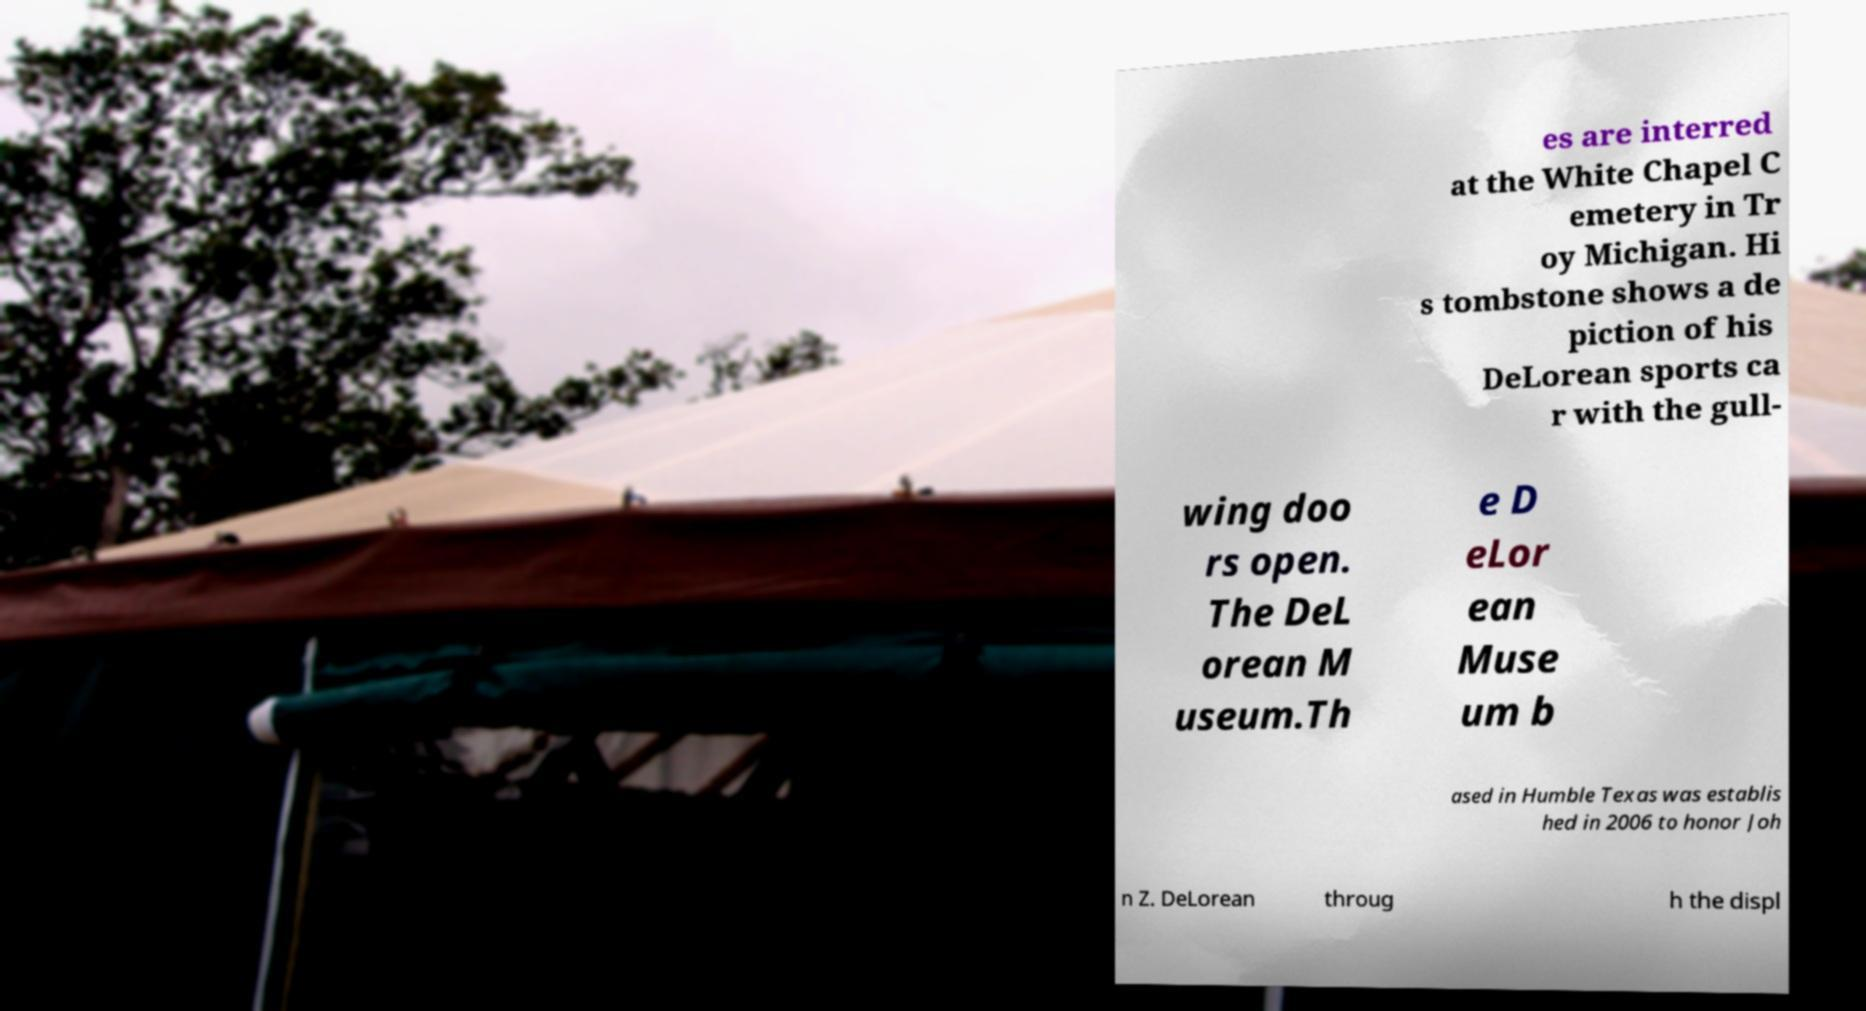Please read and relay the text visible in this image. What does it say? es are interred at the White Chapel C emetery in Tr oy Michigan. Hi s tombstone shows a de piction of his DeLorean sports ca r with the gull- wing doo rs open. The DeL orean M useum.Th e D eLor ean Muse um b ased in Humble Texas was establis hed in 2006 to honor Joh n Z. DeLorean throug h the displ 